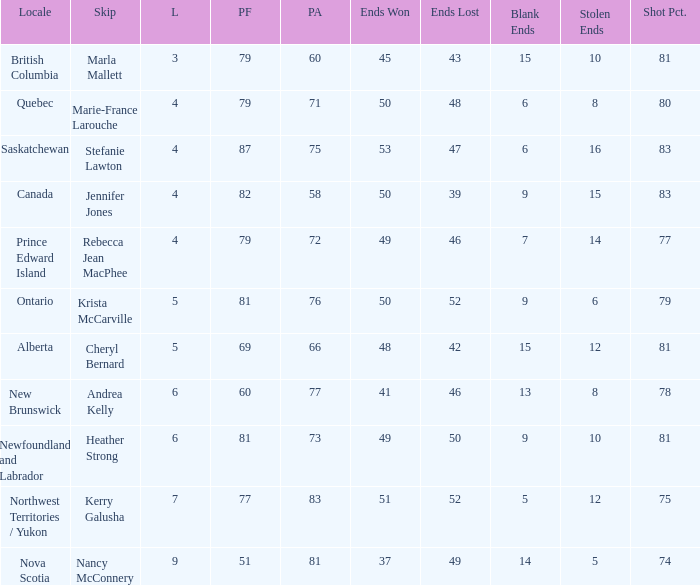What is the total of blank ends at Prince Edward Island? 7.0. 